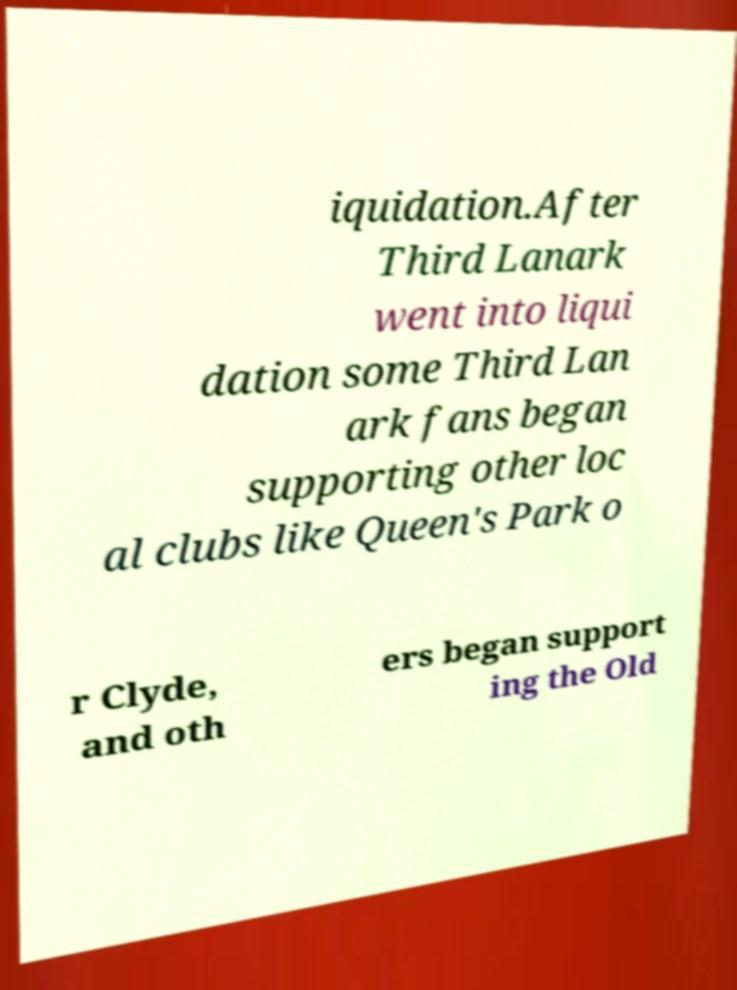Can you accurately transcribe the text from the provided image for me? iquidation.After Third Lanark went into liqui dation some Third Lan ark fans began supporting other loc al clubs like Queen's Park o r Clyde, and oth ers began support ing the Old 